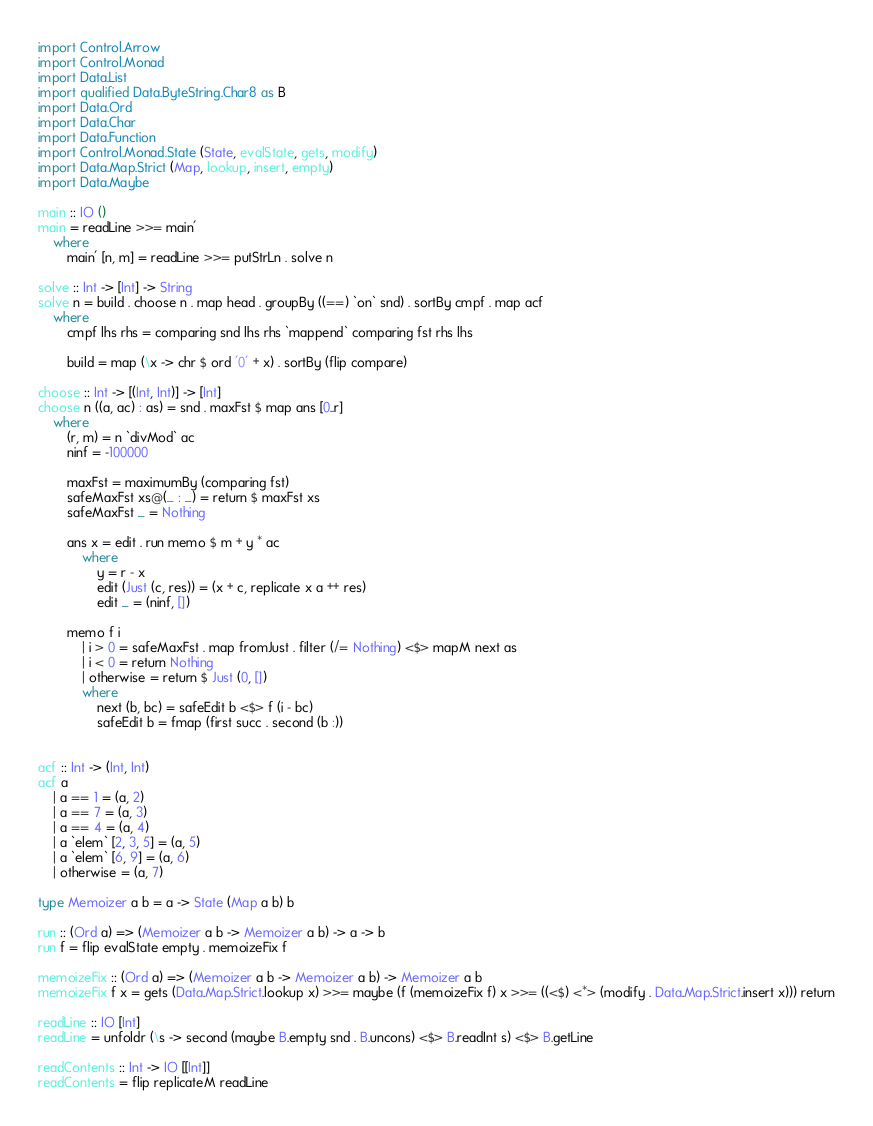Convert code to text. <code><loc_0><loc_0><loc_500><loc_500><_Haskell_>import Control.Arrow
import Control.Monad
import Data.List
import qualified Data.ByteString.Char8 as B
import Data.Ord
import Data.Char
import Data.Function
import Control.Monad.State (State, evalState, gets, modify)
import Data.Map.Strict (Map, lookup, insert, empty)
import Data.Maybe

main :: IO ()
main = readLine >>= main'
    where
        main' [n, m] = readLine >>= putStrLn . solve n

solve :: Int -> [Int] -> String
solve n = build . choose n . map head . groupBy ((==) `on` snd) . sortBy cmpf . map acf
    where
        cmpf lhs rhs = comparing snd lhs rhs `mappend` comparing fst rhs lhs

        build = map (\x -> chr $ ord '0' + x) . sortBy (flip compare)

choose :: Int -> [(Int, Int)] -> [Int]
choose n ((a, ac) : as) = snd . maxFst $ map ans [0..r]
    where
        (r, m) = n `divMod` ac
        ninf = -100000

        maxFst = maximumBy (comparing fst)
        safeMaxFst xs@(_ : _) = return $ maxFst xs 
        safeMaxFst _ = Nothing

        ans x = edit . run memo $ m + y * ac
            where
                y = r - x
                edit (Just (c, res)) = (x + c, replicate x a ++ res)
                edit _ = (ninf, [])

        memo f i
            | i > 0 = safeMaxFst . map fromJust . filter (/= Nothing) <$> mapM next as
            | i < 0 = return Nothing
            | otherwise = return $ Just (0, [])
            where
                next (b, bc) = safeEdit b <$> f (i - bc)
                safeEdit b = fmap (first succ . second (b :))


acf :: Int -> (Int, Int)
acf a
    | a == 1 = (a, 2)
    | a == 7 = (a, 3)
    | a == 4 = (a, 4)
    | a `elem` [2, 3, 5] = (a, 5)
    | a `elem` [6, 9] = (a, 6)
    | otherwise = (a, 7)

type Memoizer a b = a -> State (Map a b) b

run :: (Ord a) => (Memoizer a b -> Memoizer a b) -> a -> b
run f = flip evalState empty . memoizeFix f

memoizeFix :: (Ord a) => (Memoizer a b -> Memoizer a b) -> Memoizer a b
memoizeFix f x = gets (Data.Map.Strict.lookup x) >>= maybe (f (memoizeFix f) x >>= ((<$) <*> (modify . Data.Map.Strict.insert x))) return

readLine :: IO [Int]
readLine = unfoldr (\s -> second (maybe B.empty snd . B.uncons) <$> B.readInt s) <$> B.getLine

readContents :: Int -> IO [[Int]]
readContents = flip replicateM readLine

</code> 